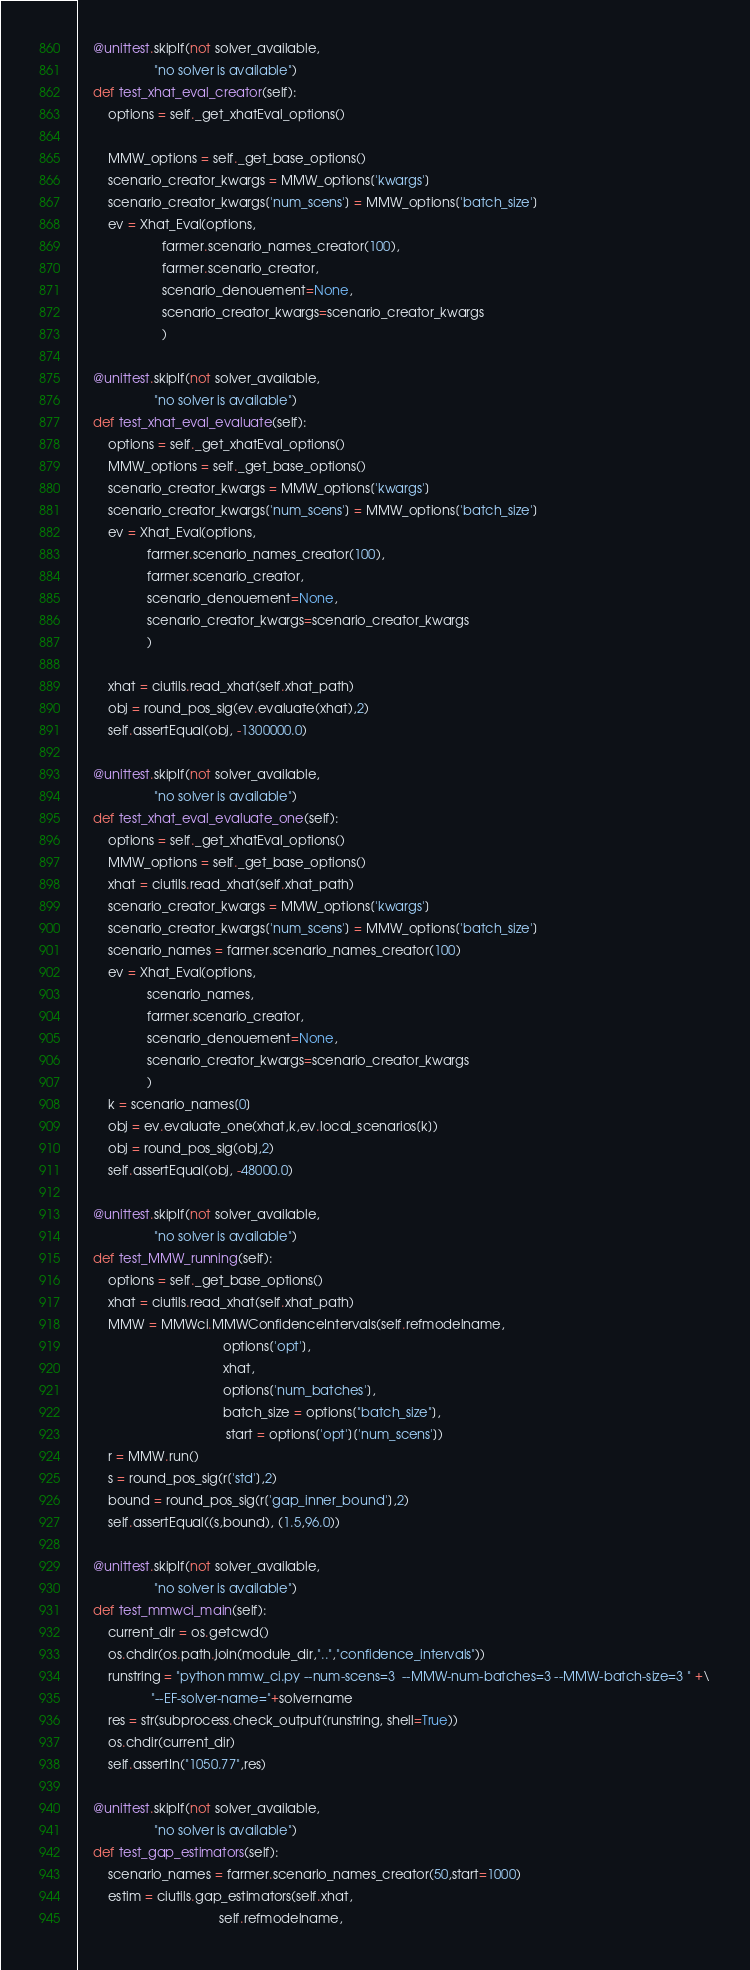Convert code to text. <code><loc_0><loc_0><loc_500><loc_500><_Python_>    @unittest.skipIf(not solver_available,
                     "no solver is available")      
    def test_xhat_eval_creator(self):
        options = self._get_xhatEval_options()
        
        MMW_options = self._get_base_options()
        scenario_creator_kwargs = MMW_options['kwargs']
        scenario_creator_kwargs['num_scens'] = MMW_options['batch_size']
        ev = Xhat_Eval(options,
                       farmer.scenario_names_creator(100),
                       farmer.scenario_creator,
                       scenario_denouement=None,
                       scenario_creator_kwargs=scenario_creator_kwargs
                       )
        
    @unittest.skipIf(not solver_available,
                     "no solver is available")      
    def test_xhat_eval_evaluate(self):
        options = self._get_xhatEval_options()
        MMW_options = self._get_base_options()
        scenario_creator_kwargs = MMW_options['kwargs']
        scenario_creator_kwargs['num_scens'] = MMW_options['batch_size']
        ev = Xhat_Eval(options,
                   farmer.scenario_names_creator(100),
                   farmer.scenario_creator,
                   scenario_denouement=None,
                   scenario_creator_kwargs=scenario_creator_kwargs
                   )
        
        xhat = ciutils.read_xhat(self.xhat_path)
        obj = round_pos_sig(ev.evaluate(xhat),2)
        self.assertEqual(obj, -1300000.0)
 
    @unittest.skipIf(not solver_available,
                     "no solver is available")  
    def test_xhat_eval_evaluate_one(self):
        options = self._get_xhatEval_options()
        MMW_options = self._get_base_options()
        xhat = ciutils.read_xhat(self.xhat_path)
        scenario_creator_kwargs = MMW_options['kwargs']
        scenario_creator_kwargs['num_scens'] = MMW_options['batch_size']
        scenario_names = farmer.scenario_names_creator(100)
        ev = Xhat_Eval(options,
                   scenario_names,
                   farmer.scenario_creator,
                   scenario_denouement=None,
                   scenario_creator_kwargs=scenario_creator_kwargs
                   )
        k = scenario_names[0]
        obj = ev.evaluate_one(xhat,k,ev.local_scenarios[k])
        obj = round_pos_sig(obj,2)
        self.assertEqual(obj, -48000.0)
      
    @unittest.skipIf(not solver_available,
                     "no solver is available")  
    def test_MMW_running(self):
        options = self._get_base_options()
        xhat = ciutils.read_xhat(self.xhat_path)
        MMW = MMWci.MMWConfidenceIntervals(self.refmodelname,
                                        options['opt'],
                                        xhat,
                                        options['num_batches'],
                                        batch_size = options["batch_size"],
                                         start = options['opt']['num_scens'])
        r = MMW.run() 
        s = round_pos_sig(r['std'],2)
        bound = round_pos_sig(r['gap_inner_bound'],2)
        self.assertEqual((s,bound), (1.5,96.0))
   
    @unittest.skipIf(not solver_available,
                     "no solver is available")
    def test_mmwci_main(self):
        current_dir = os.getcwd()
        os.chdir(os.path.join(module_dir,"..","confidence_intervals"))
        runstring = "python mmw_ci.py --num-scens=3  --MMW-num-batches=3 --MMW-batch-size=3 " +\
                    "--EF-solver-name="+solvername
        res = str(subprocess.check_output(runstring, shell=True))
        os.chdir(current_dir)
        self.assertIn("1050.77",res)
    
    @unittest.skipIf(not solver_available,
                     "no solver is available")
    def test_gap_estimators(self):
        scenario_names = farmer.scenario_names_creator(50,start=1000)
        estim = ciutils.gap_estimators(self.xhat,
                                       self.refmodelname,</code> 